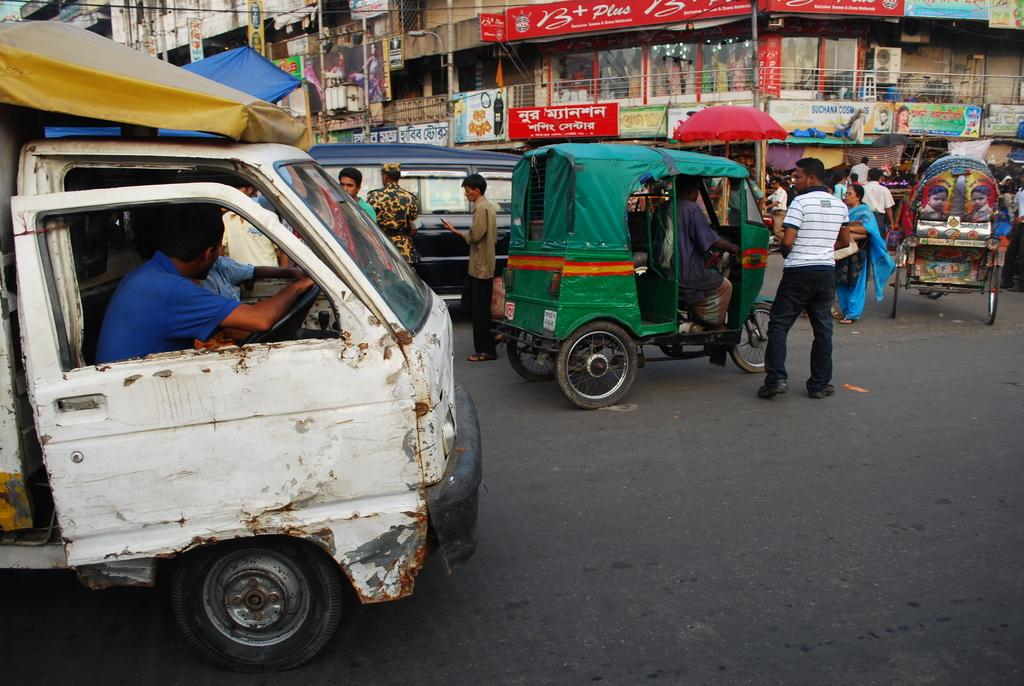<image>
Describe the image concisely. traffic on a street in front of a banner saying suchana 